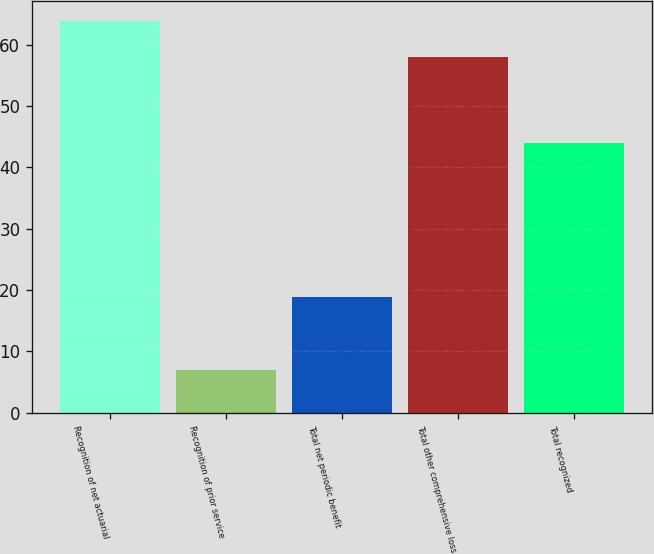Convert chart. <chart><loc_0><loc_0><loc_500><loc_500><bar_chart><fcel>Recognition of net actuarial<fcel>Recognition of prior service<fcel>Total net periodic benefit<fcel>Total other comprehensive loss<fcel>Total recognized<nl><fcel>63.9<fcel>6.9<fcel>18.9<fcel>58<fcel>44<nl></chart> 